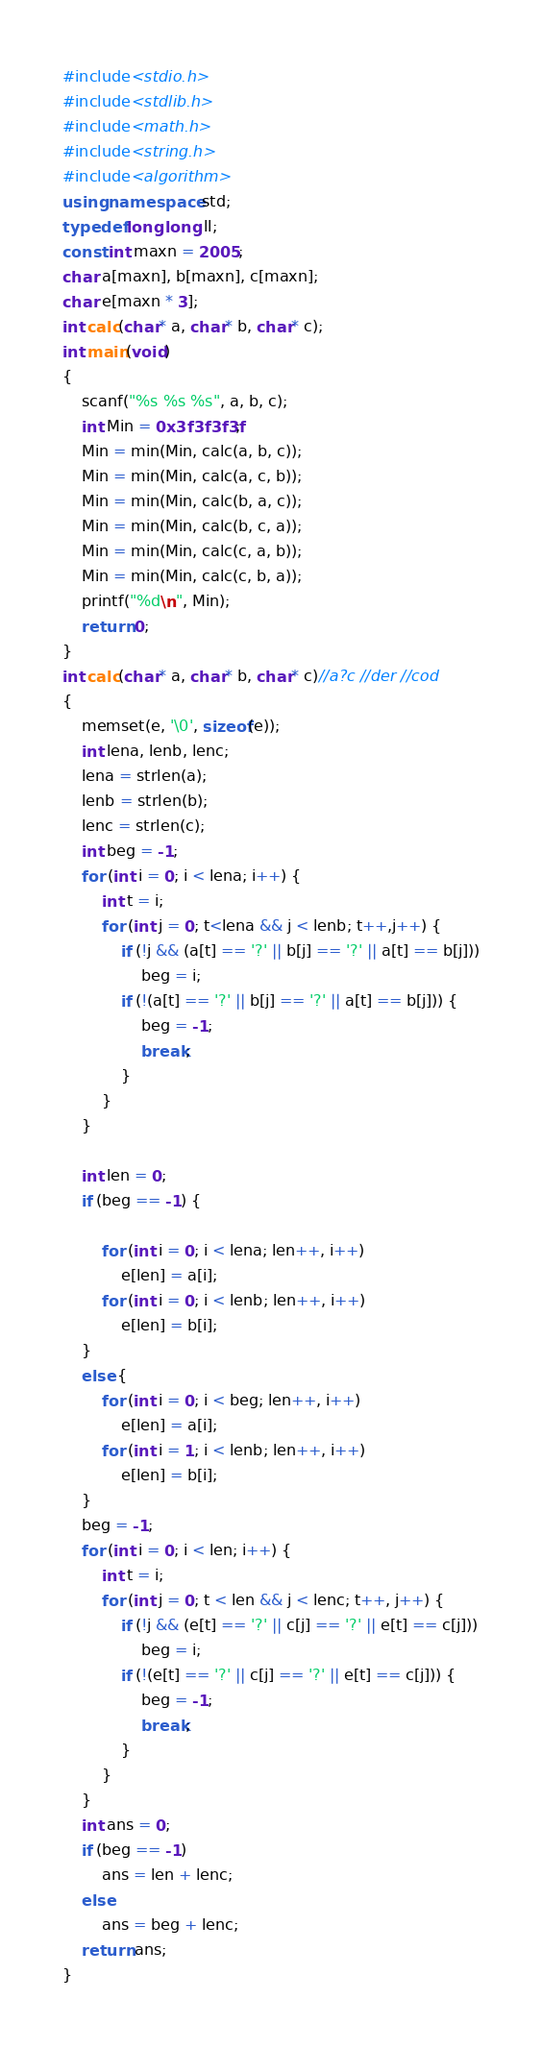<code> <loc_0><loc_0><loc_500><loc_500><_C++_>#include<stdio.h>
#include<stdlib.h>
#include<math.h>
#include<string.h>
#include<algorithm>
using namespace std;
typedef long long ll;
const int maxn = 2005;
char a[maxn], b[maxn], c[maxn];
char e[maxn * 3];
int calc(char* a, char* b, char* c);
int main(void)
{
	scanf("%s %s %s", a, b, c);
	int Min = 0x3f3f3f3f;
	Min = min(Min, calc(a, b, c));
	Min = min(Min, calc(a, c, b));
	Min = min(Min, calc(b, a, c));
	Min = min(Min, calc(b, c, a));
	Min = min(Min, calc(c, a, b));
	Min = min(Min, calc(c, b, a));
	printf("%d\n", Min);
	return 0;
}
int calc(char* a, char* b, char* c)//a?c //der //cod
{
	memset(e, '\0', sizeof(e));
	int lena, lenb, lenc;
	lena = strlen(a);
	lenb = strlen(b);
	lenc = strlen(c);
	int beg = -1;
	for (int i = 0; i < lena; i++) {
		int t = i;
		for (int j = 0; t<lena && j < lenb; t++,j++) {
			if (!j && (a[t] == '?' || b[j] == '?' || a[t] == b[j]))
				beg = i;
			if (!(a[t] == '?' || b[j] == '?' || a[t] == b[j])) {
				beg = -1;
				break;
			}
		}
	}

	int len = 0;
	if (beg == -1) {

		for (int i = 0; i < lena; len++, i++)
			e[len] = a[i];
		for (int i = 0; i < lenb; len++, i++)
			e[len] = b[i];
	}
	else {
		for (int i = 0; i < beg; len++, i++)
			e[len] = a[i];
		for (int i = 1; i < lenb; len++, i++)
			e[len] = b[i];
	}
	beg = -1;
	for (int i = 0; i < len; i++) {
		int t = i;
		for (int j = 0; t < len && j < lenc; t++, j++) {
			if (!j && (e[t] == '?' || c[j] == '?' || e[t] == c[j]))
				beg = i;
			if (!(e[t] == '?' || c[j] == '?' || e[t] == c[j])) {
				beg = -1;
				break;
			}
		}
	}
	int ans = 0;
	if (beg == -1)
		ans = len + lenc;
	else
		ans = beg + lenc;
	return ans;
}</code> 